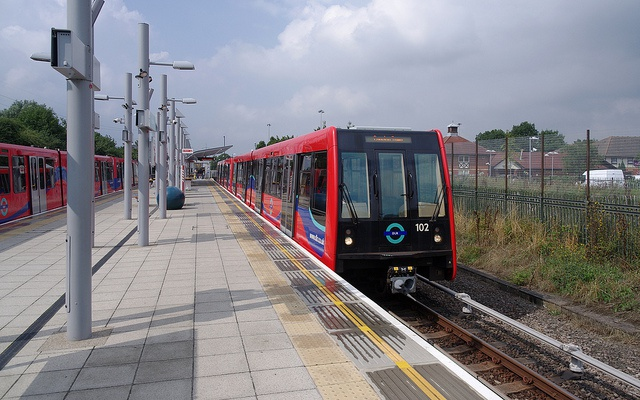Describe the objects in this image and their specific colors. I can see train in lavender, black, gray, and blue tones, train in lavender, black, maroon, gray, and purple tones, and truck in lavender, darkgray, and gray tones in this image. 